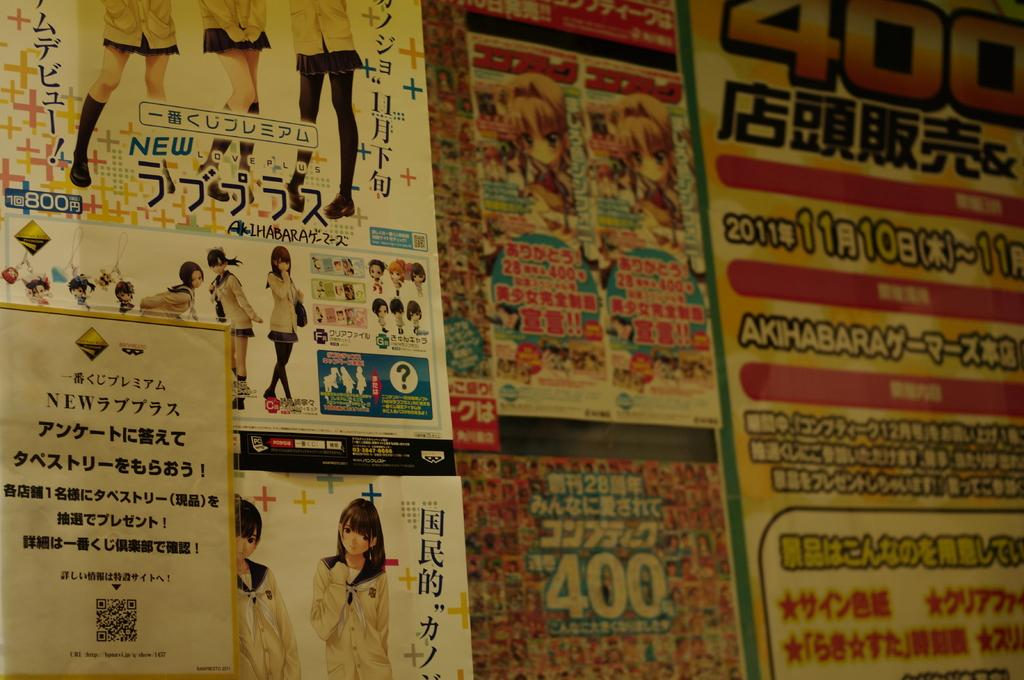<image>
Describe the image concisely. Posters on a wall including one that has the number 400. 